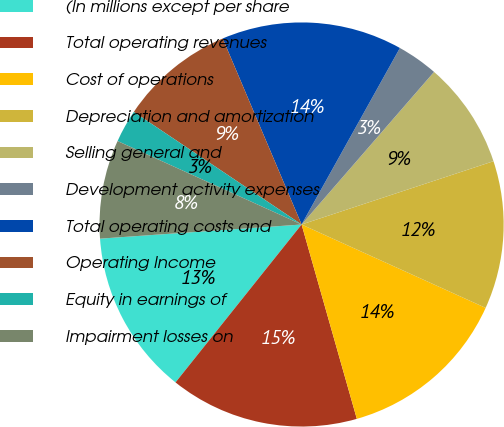<chart> <loc_0><loc_0><loc_500><loc_500><pie_chart><fcel>(In millions except per share<fcel>Total operating revenues<fcel>Cost of operations<fcel>Depreciation and amortization<fcel>Selling general and<fcel>Development activity expenses<fcel>Total operating costs and<fcel>Operating Income<fcel>Equity in earnings of<fcel>Impairment losses on<nl><fcel>13.16%<fcel>15.13%<fcel>13.82%<fcel>11.84%<fcel>8.55%<fcel>3.29%<fcel>14.47%<fcel>9.21%<fcel>2.63%<fcel>7.89%<nl></chart> 